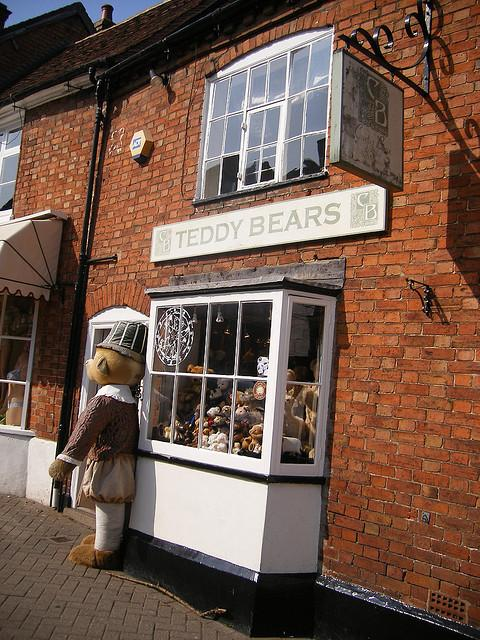What stuffed animal is sold here? Please explain your reasoning. bears. There is a sign above the display window. 